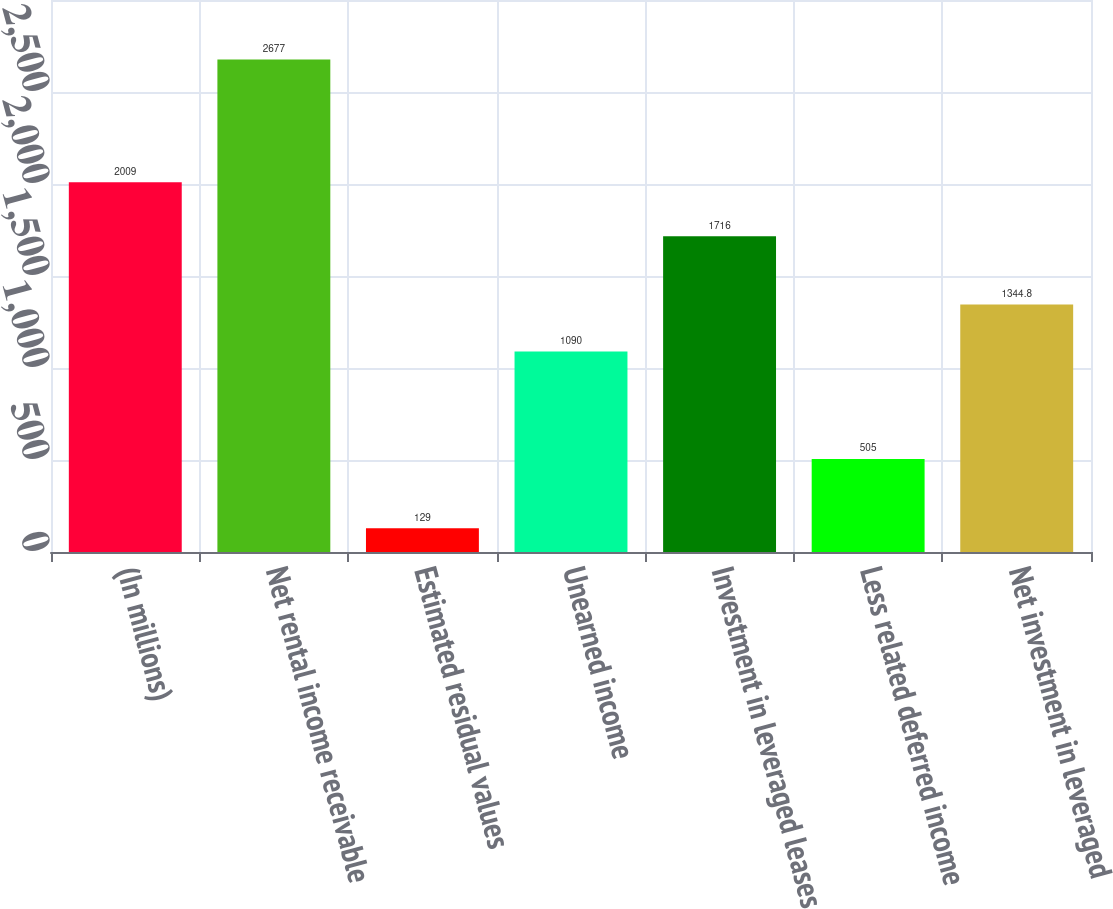<chart> <loc_0><loc_0><loc_500><loc_500><bar_chart><fcel>(In millions)<fcel>Net rental income receivable<fcel>Estimated residual values<fcel>Unearned income<fcel>Investment in leveraged leases<fcel>Less related deferred income<fcel>Net investment in leveraged<nl><fcel>2009<fcel>2677<fcel>129<fcel>1090<fcel>1716<fcel>505<fcel>1344.8<nl></chart> 